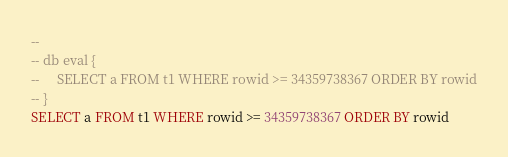<code> <loc_0><loc_0><loc_500><loc_500><_SQL_>-- 
-- db eval {
--     SELECT a FROM t1 WHERE rowid >= 34359738367 ORDER BY rowid
-- }
SELECT a FROM t1 WHERE rowid >= 34359738367 ORDER BY rowid</code> 